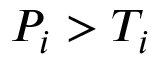<formula> <loc_0><loc_0><loc_500><loc_500>P _ { i } > T _ { i }</formula> 